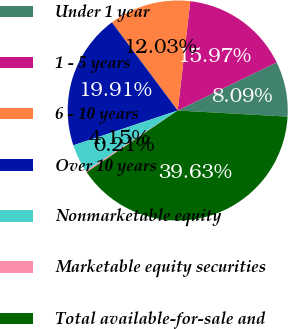<chart> <loc_0><loc_0><loc_500><loc_500><pie_chart><fcel>Under 1 year<fcel>1 - 5 years<fcel>6 - 10 years<fcel>Over 10 years<fcel>Nonmarketable equity<fcel>Marketable equity securities<fcel>Total available-for-sale and<nl><fcel>8.09%<fcel>15.97%<fcel>12.03%<fcel>19.91%<fcel>4.15%<fcel>0.21%<fcel>39.62%<nl></chart> 